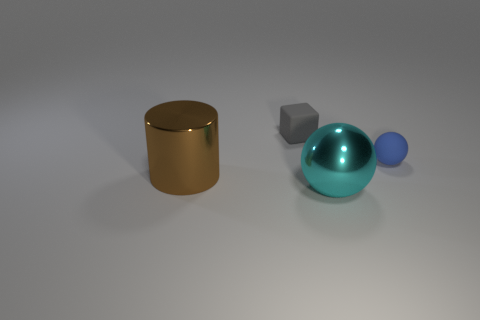Add 1 big purple metallic spheres. How many objects exist? 5 Subtract all large brown balls. Subtract all spheres. How many objects are left? 2 Add 1 blue objects. How many blue objects are left? 2 Add 1 gray rubber blocks. How many gray rubber blocks exist? 2 Subtract 1 cyan balls. How many objects are left? 3 